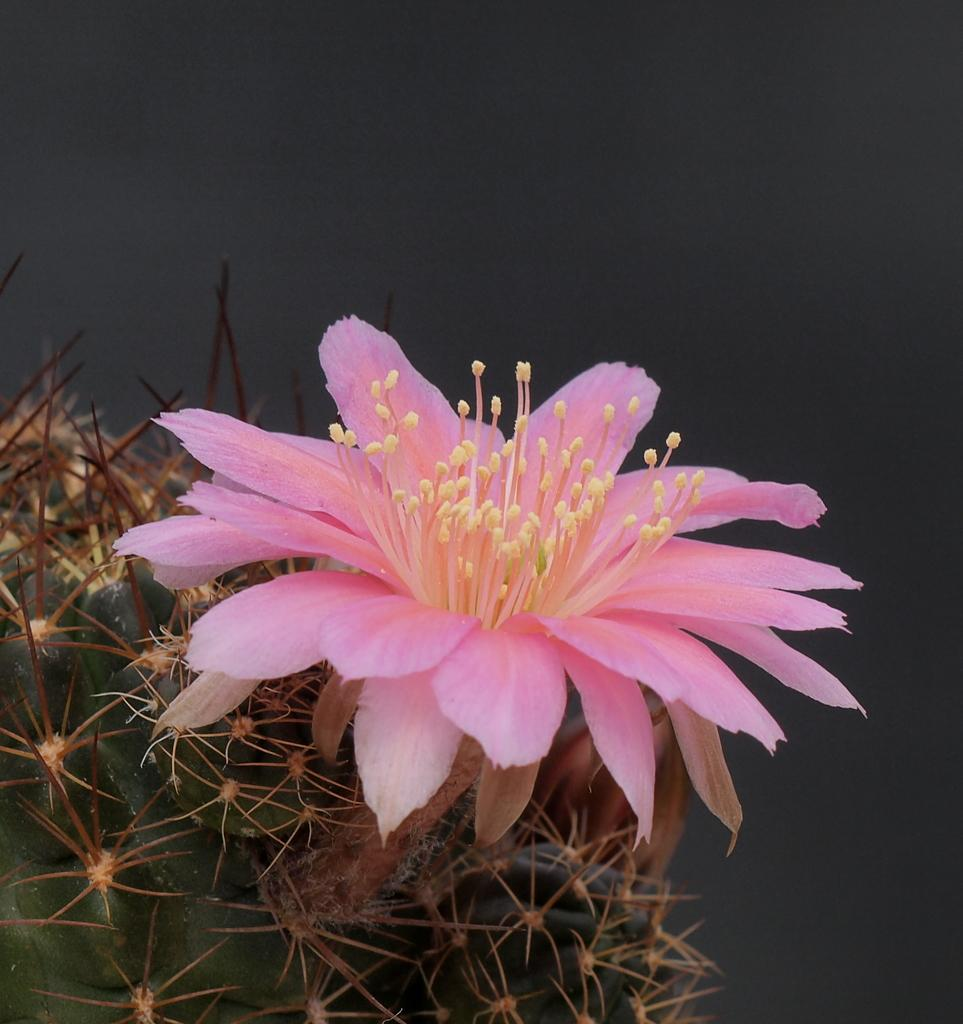What type of flower is present in the image? There is a pink color flower in the image. Can you describe any other part of the flower besides its color? Unfortunately, the provided facts do not mention any other details about the flower. What is located in the left bottom of the image? There is a green color stem-like thing in the left bottom of the image. What type of locket can be seen hanging from the flower in the image? There is no locket present in the image; it only features a pink color flower and a green color stem-like thing. 